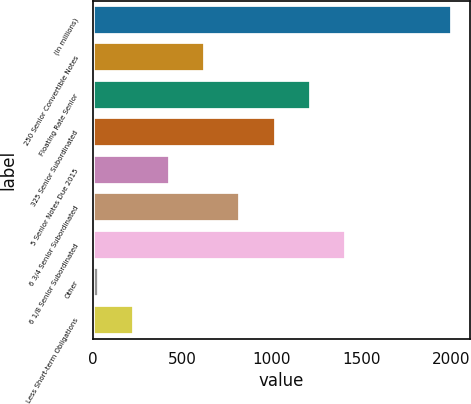Convert chart. <chart><loc_0><loc_0><loc_500><loc_500><bar_chart><fcel>(In millions)<fcel>250 Senior Convertible Notes<fcel>Floating Rate Senior<fcel>325 Senior Subordinated<fcel>5 Senior Notes Due 2015<fcel>6 3/4 Senior Subordinated<fcel>6 1/8 Senior Subordinated<fcel>Other<fcel>Less Short-term Obligations<nl><fcel>2007<fcel>625.83<fcel>1217.76<fcel>1020.45<fcel>428.52<fcel>823.14<fcel>1415.07<fcel>33.9<fcel>231.21<nl></chart> 